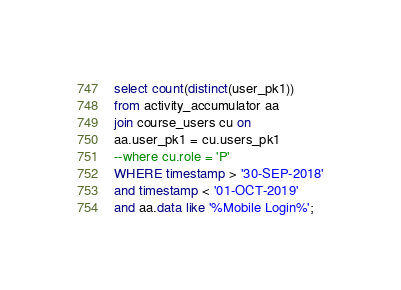Convert code to text. <code><loc_0><loc_0><loc_500><loc_500><_SQL_>select count(distinct(user_pk1))
from activity_accumulator aa
join course_users cu on
aa.user_pk1 = cu.users_pk1
--where cu.role = 'P'
WHERE timestamp > '30-SEP-2018'
and timestamp < '01-OCT-2019'
and aa.data like '%Mobile Login%';</code> 